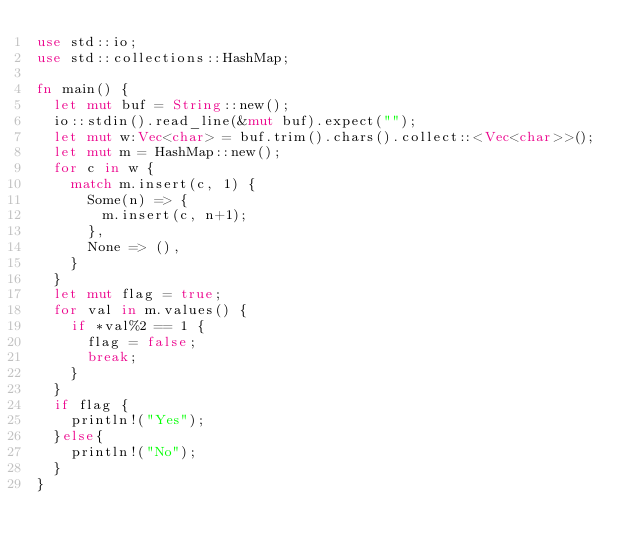Convert code to text. <code><loc_0><loc_0><loc_500><loc_500><_Rust_>use std::io;
use std::collections::HashMap;

fn main() {
	let mut buf = String::new();
	io::stdin().read_line(&mut buf).expect("");
	let mut w:Vec<char> = buf.trim().chars().collect::<Vec<char>>();
	let mut m = HashMap::new();
	for c in w {
		match m.insert(c, 1) {
			Some(n) => {
				m.insert(c, n+1);
			},
			None => (),
		}
	}
	let mut flag = true;
	for val in m.values() {
		if *val%2 == 1 {
			flag = false;
			break;
		}
	}
	if flag {
		println!("Yes");
	}else{
		println!("No");
	}
}</code> 